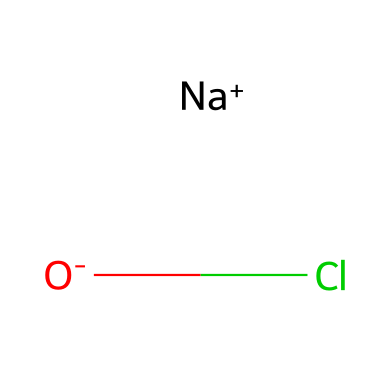what is the oxidation state of chlorine in sodium hypochlorite? The oxidation state of an element can be determined by analyzing its bonding and charge. In sodium hypochlorite, the chlorine atom (Cl) is bonded to an oxygen atom (O) which is negatively charged. Thus, in order for the compound to remain neutral overall (Na is positively charged), chlorine must have an oxidation state of +1.
Answer: +1 how many total atoms are in sodium hypochlorite? To find the total number of atoms, you add the individual atoms: 1 sodium (Na), 1 chlorine (Cl), and 1 oxygen (O), making a total of 3 atoms.
Answer: 3 which elements are present in sodium hypochlorite? The chemical structure shows three components: sodium (Na), chlorine (Cl), and oxygen (O). Thus, the elements present are sodium, chlorine, and oxygen.
Answer: sodium, chlorine, oxygen what is the role of sodium hypochlorite in cleaning? Sodium hypochlorite is a well-known oxidizer that serves as a disinfectant and bleaching agent. It works by releasing chlorine in solution, which effectively kills bacteria and other pathogens, making it an essential compound for cleaning purposes.
Answer: disinfectant, bleaching agent is sodium hypochlorite a strong oxidizer? Yes, sodium hypochlorite is considered a strong oxidizer. It can readily react with other substances, facilitating oxidation reactions, which is why it is effective in cleaning and disinfecting.
Answer: yes how many bonds are present in sodium hypochlorite? In sodium hypochlorite, there are two types of bonds: one bond between sodium (Na) and the hypochlorite ion (ClO), and a covalent bond between chlorine (Cl) and oxygen (O) within the hypochlorite ion. Counting these, there are 2 significant bonds in total.
Answer: 2 